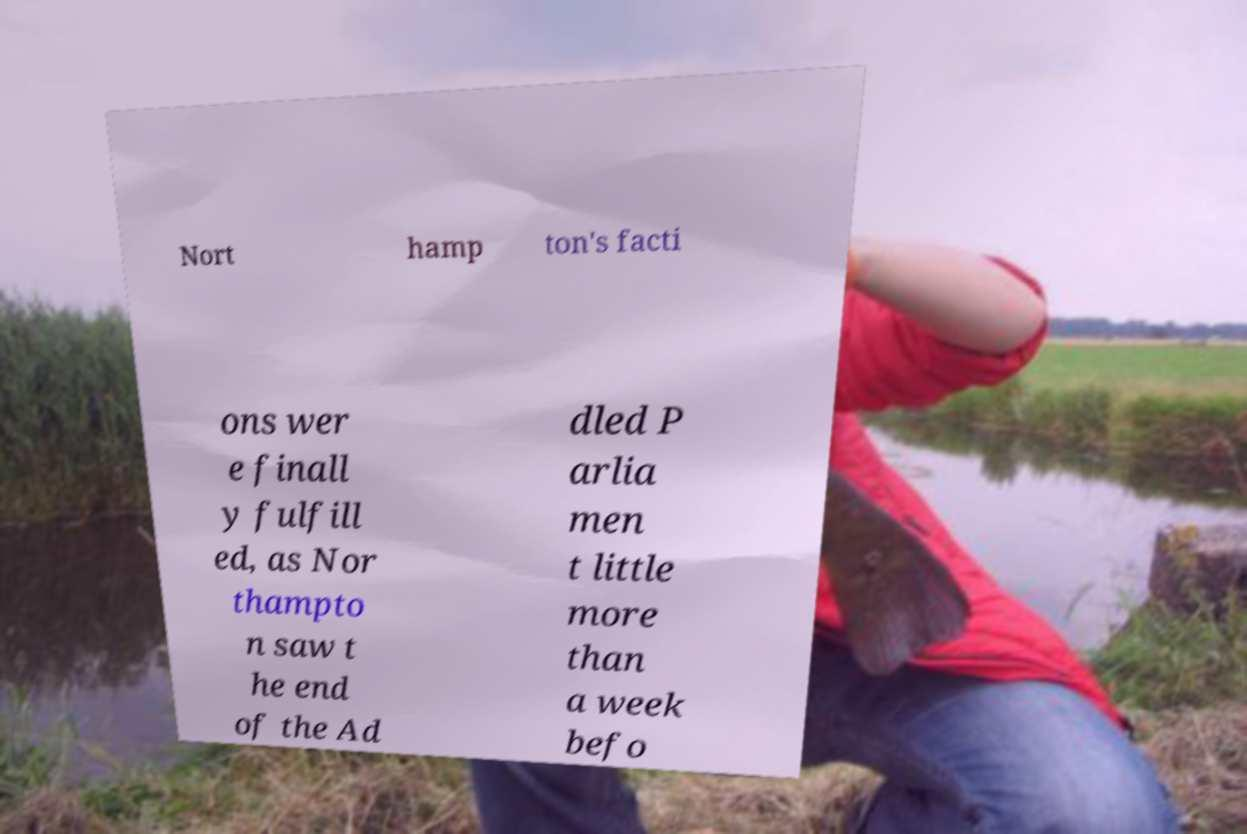Can you accurately transcribe the text from the provided image for me? Nort hamp ton's facti ons wer e finall y fulfill ed, as Nor thampto n saw t he end of the Ad dled P arlia men t little more than a week befo 